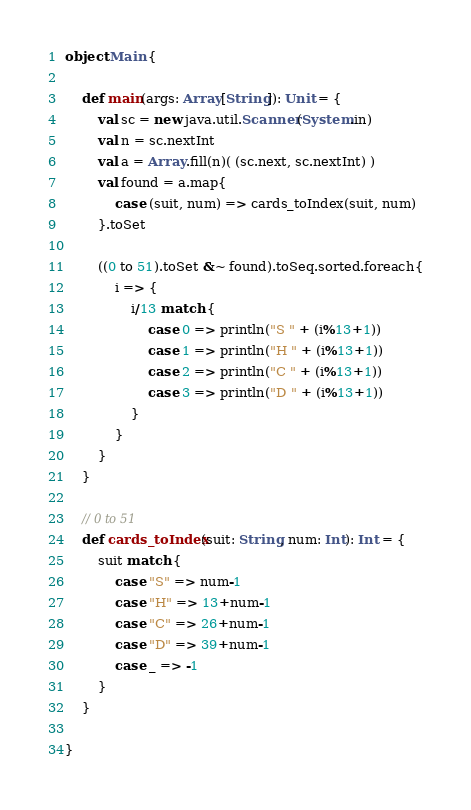<code> <loc_0><loc_0><loc_500><loc_500><_Scala_>object Main {

    def main(args: Array[String]): Unit = {
        val sc = new java.util.Scanner(System.in)
        val n = sc.nextInt
        val a = Array.fill(n)( (sc.next, sc.nextInt) )
        val found = a.map{
            case (suit, num) => cards_toIndex(suit, num)
        }.toSet

        ((0 to 51).toSet &~ found).toSeq.sorted.foreach{
            i => {
                i/13 match {
                    case 0 => println("S " + (i%13+1))
                    case 1 => println("H " + (i%13+1))
                    case 2 => println("C " + (i%13+1))
                    case 3 => println("D " + (i%13+1))
                }
            }
        }
    }

    // 0 to 51
    def cards_toIndex(suit: String, num: Int): Int = {
        suit match {
            case "S" => num-1
            case "H" => 13+num-1
            case "C" => 26+num-1
            case "D" => 39+num-1
            case _ => -1
        }
    }

}

</code> 